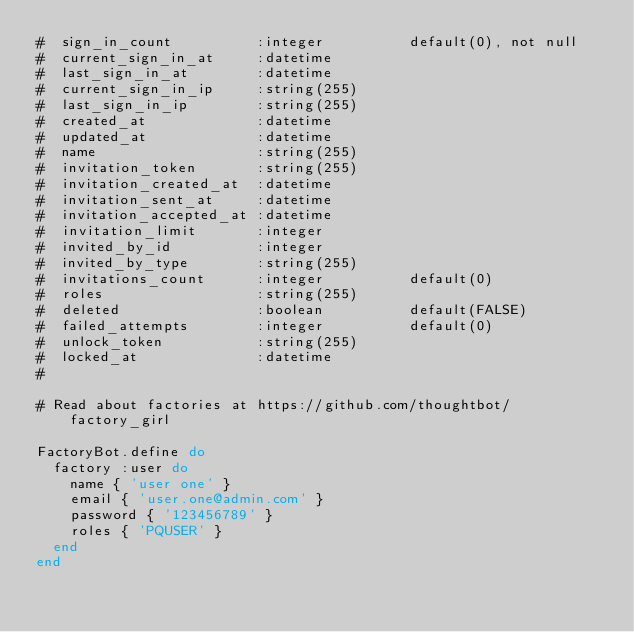<code> <loc_0><loc_0><loc_500><loc_500><_Ruby_>#  sign_in_count          :integer          default(0), not null
#  current_sign_in_at     :datetime
#  last_sign_in_at        :datetime
#  current_sign_in_ip     :string(255)
#  last_sign_in_ip        :string(255)
#  created_at             :datetime
#  updated_at             :datetime
#  name                   :string(255)
#  invitation_token       :string(255)
#  invitation_created_at  :datetime
#  invitation_sent_at     :datetime
#  invitation_accepted_at :datetime
#  invitation_limit       :integer
#  invited_by_id          :integer
#  invited_by_type        :string(255)
#  invitations_count      :integer          default(0)
#  roles                  :string(255)
#  deleted                :boolean          default(FALSE)
#  failed_attempts        :integer          default(0)
#  unlock_token           :string(255)
#  locked_at              :datetime
#

# Read about factories at https://github.com/thoughtbot/factory_girl

FactoryBot.define do
  factory :user do
    name { 'user one' }
    email { 'user.one@admin.com' }
    password { '123456789' }
    roles { 'PQUSER' }
  end
end
</code> 